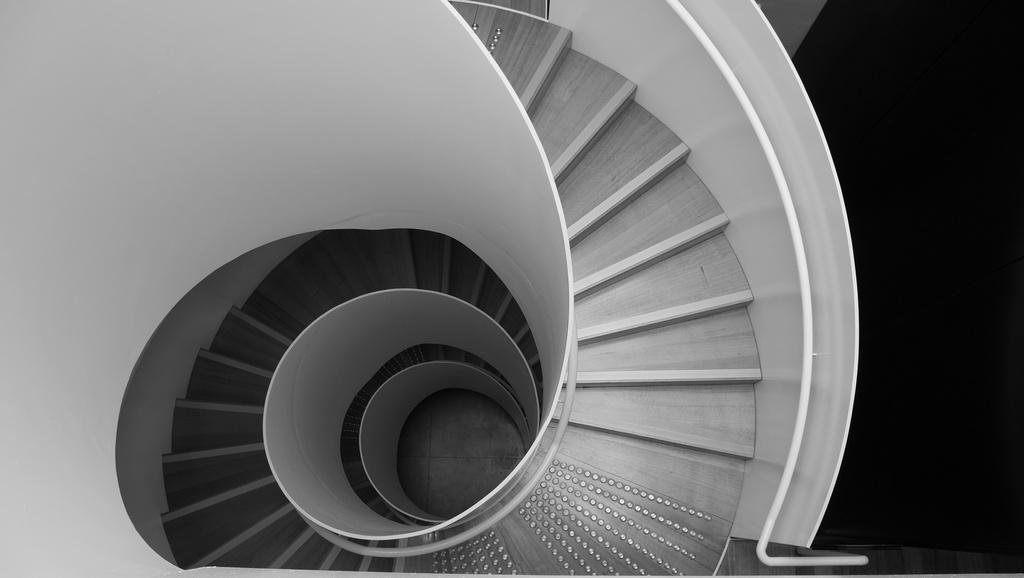What type of structure is present in the image? There are stairs in the image. What can you tell me about the color scheme of the image? The image is black and white in color. Can you compare the number of spiders in the image to the number of spiders in a different image? There are no spiders present in the image, so it is not possible to make a comparison. 